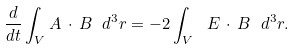<formula> <loc_0><loc_0><loc_500><loc_500>\frac { d } { d t } \int _ { V } { A } \, \cdot \, { B } \ d ^ { 3 } r = - 2 \int _ { V } \ { E } \, \cdot \, { B } \ d ^ { 3 } r .</formula> 